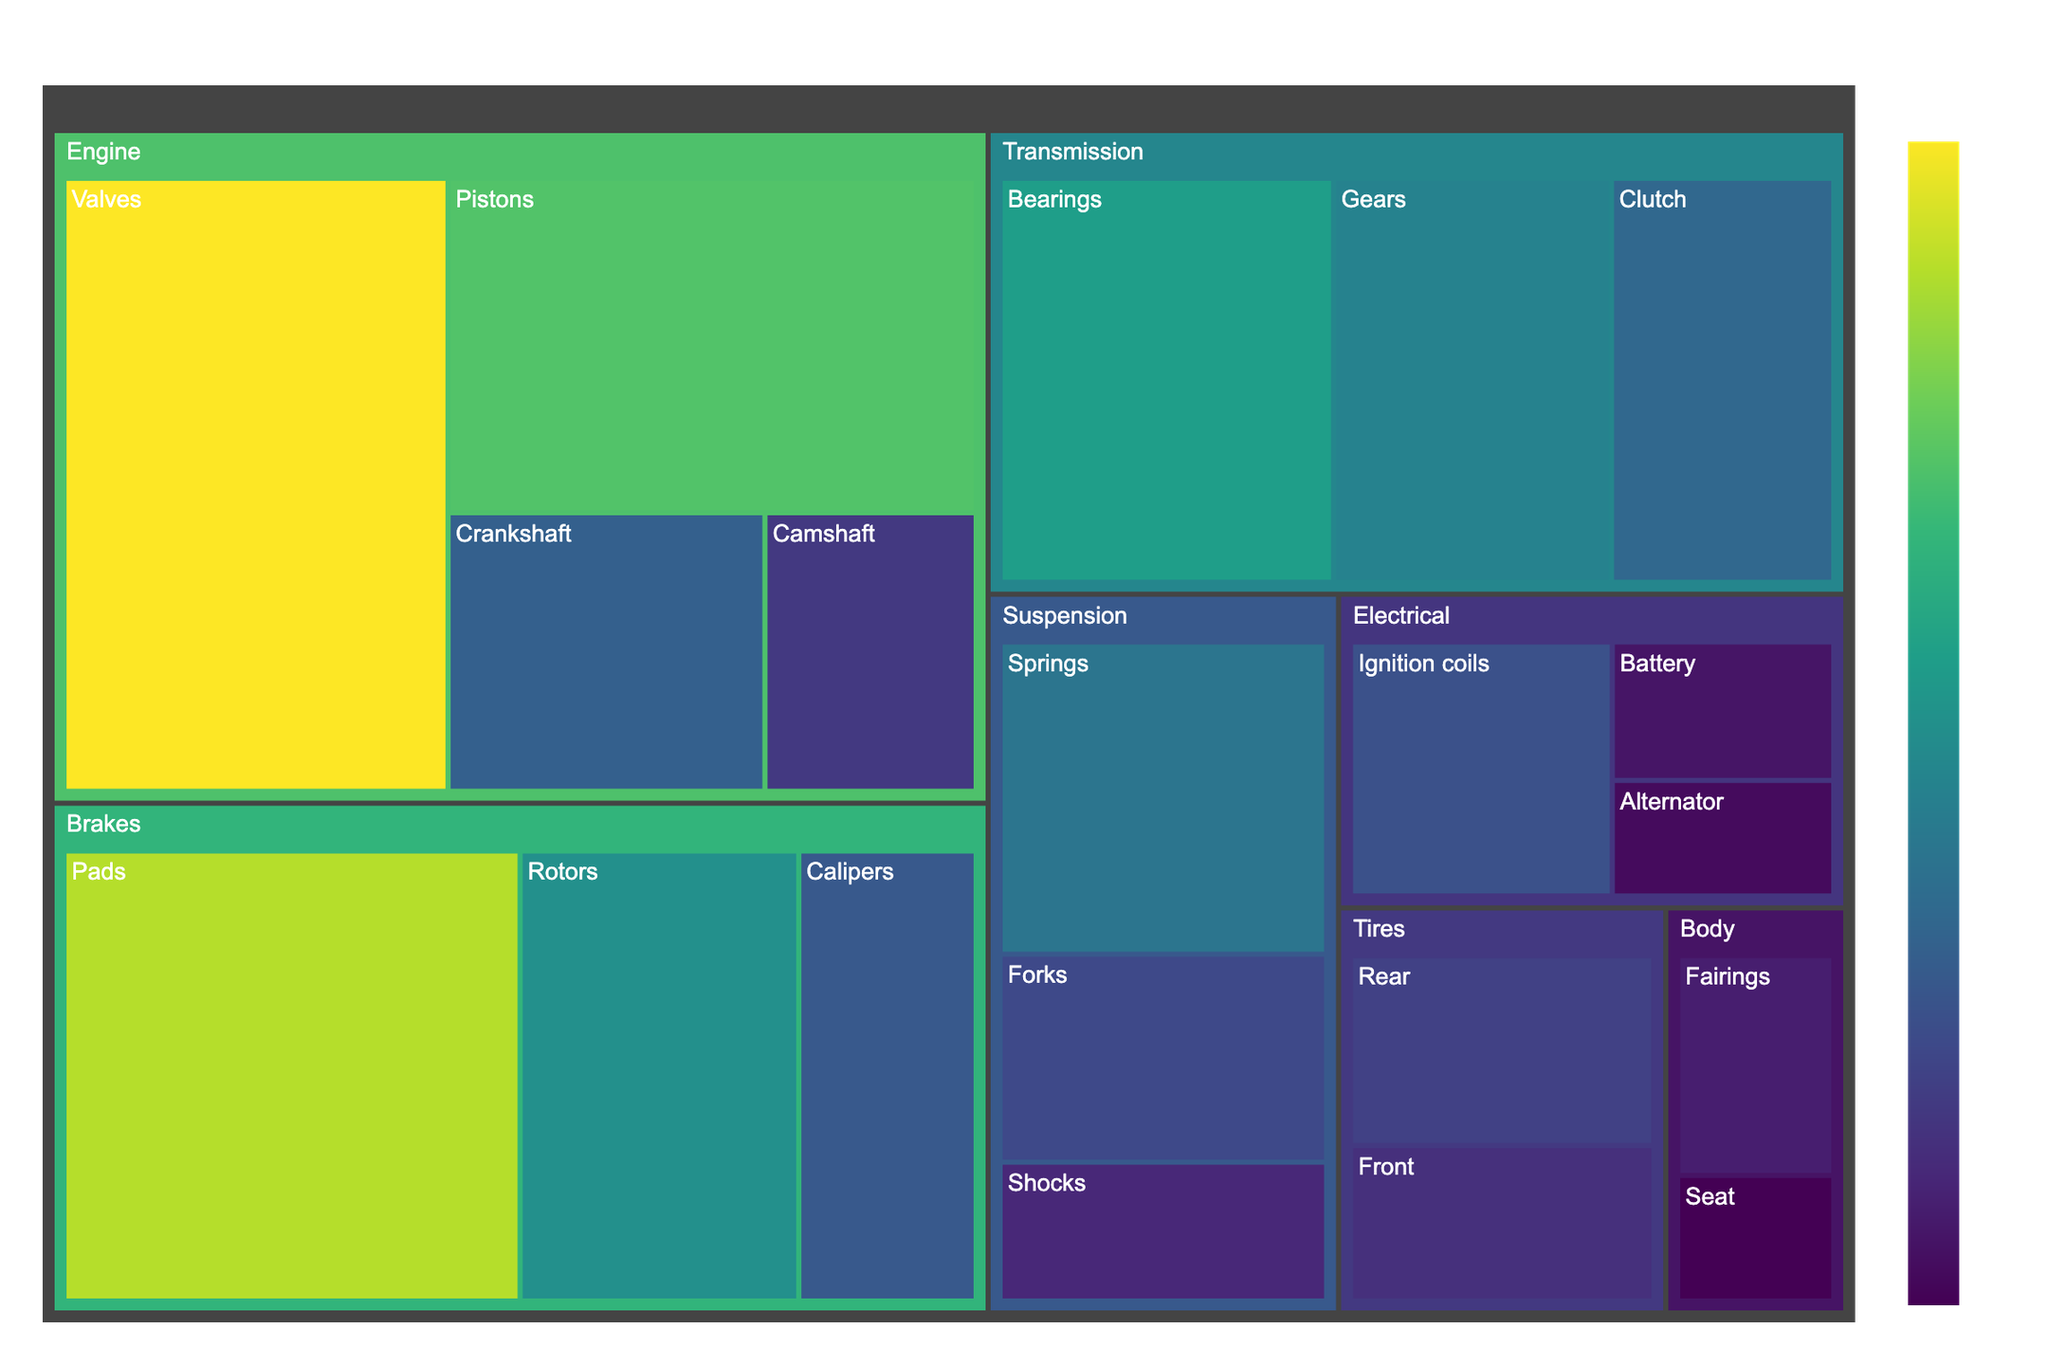Which category has the highest quantity of parts overall? To determine which category has the highest quantity, sum the values corresponding to each subcategory within that category. For example, for the Engine category, sum Pistons (150), Valves (200), Crankshaft (75), and Camshaft (50) to get 475. Repeat this for other categories. The category with the highest sum of values is the one with the highest quantity of parts.
Answer: Engine What is the total quantity of Electrical parts? Identify all the subcategories under Electrical—Battery (30), Alternator (25), and Ignition coils (65). Sum these values to get the total quantity.
Answer: 120 Which subcategory within the Brakes category has the highest quantity? Compare the quantities of Calipers (70), Rotors (110), and Pads (180). The subcategory with the highest quantity is Pads.
Answer: Pads What is the proportion of Suspension parts relative to the total inventory? First, find the total quantity for the Suspension category by summing Forks (60), Shocks (40), and Springs (90), which gives 190. Then, sum the values of all subcategories across all categories to find the total inventory quantity. Divide the Suspension total by the overall total and multiply by 100 to get the percentage.
Answer: 15.83% Which category has the least quantity of parts overall? Sum the values for each category and compare the totals. The category with the smallest sum is the one with the least quantity of parts.
Answer: Body How many more parts are there in the Transmission category compared to the Tires category? Sum the values of subcategories in Transmission—Gears (100), Clutch (80), and Bearings (120) to get 300. Sum the values for Tires—Front (45) and Rear (55) to get 100. Subtract the total for Tires from the total for Transmission.
Answer: 200 Which category has the second highest quantity of parts? Calculate the total quantity for each category and rank them in descending order. The category with the second highest total will be next in line after the Engine category.
Answer: Brakes Are there more parts in the Engine or the Transmission category? Sum the values for the Engine category and compare it to the sum of the values for the Transmission category. The category with the higher sum has more parts.
Answer: Engine What is the average quantity of parts per subcategory in the Tires category? Sum the values for the Front (45) and Rear (55) subcategories to get 100. Divide this sum by the number of subcategories (2).
Answer: 50 What is the difference in quantity between the largest and smallest subcategories within the Electrical category? Identify the subcategory with the largest quantity (Ignition coils, 65) and the smallest quantity (Alternator, 25). Subtract the smallest value from the largest value.
Answer: 40 